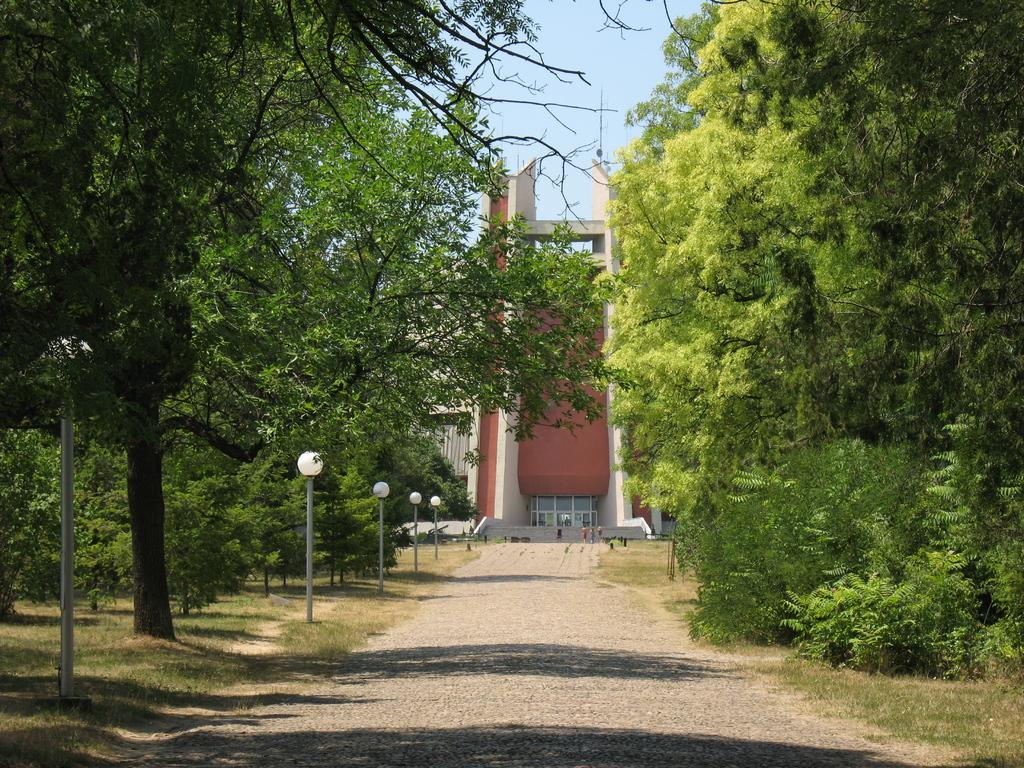Could you give a brief overview of what you see in this image? In this image we can see a road. On the left side there are trees. Also there are light poles. On the right side also there are trees. In the background there is a building. At the top there is sky. On the ground there is grass. 